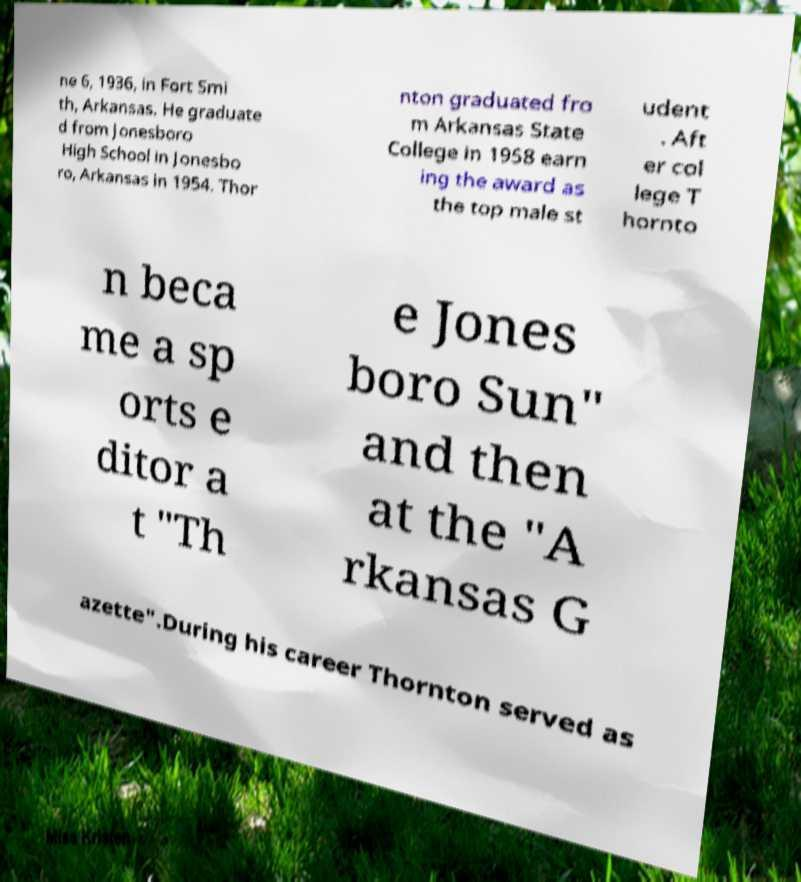Please read and relay the text visible in this image. What does it say? ne 6, 1936, in Fort Smi th, Arkansas. He graduate d from Jonesboro High School in Jonesbo ro, Arkansas in 1954. Thor nton graduated fro m Arkansas State College in 1958 earn ing the award as the top male st udent . Aft er col lege T hornto n beca me a sp orts e ditor a t "Th e Jones boro Sun" and then at the "A rkansas G azette".During his career Thornton served as 